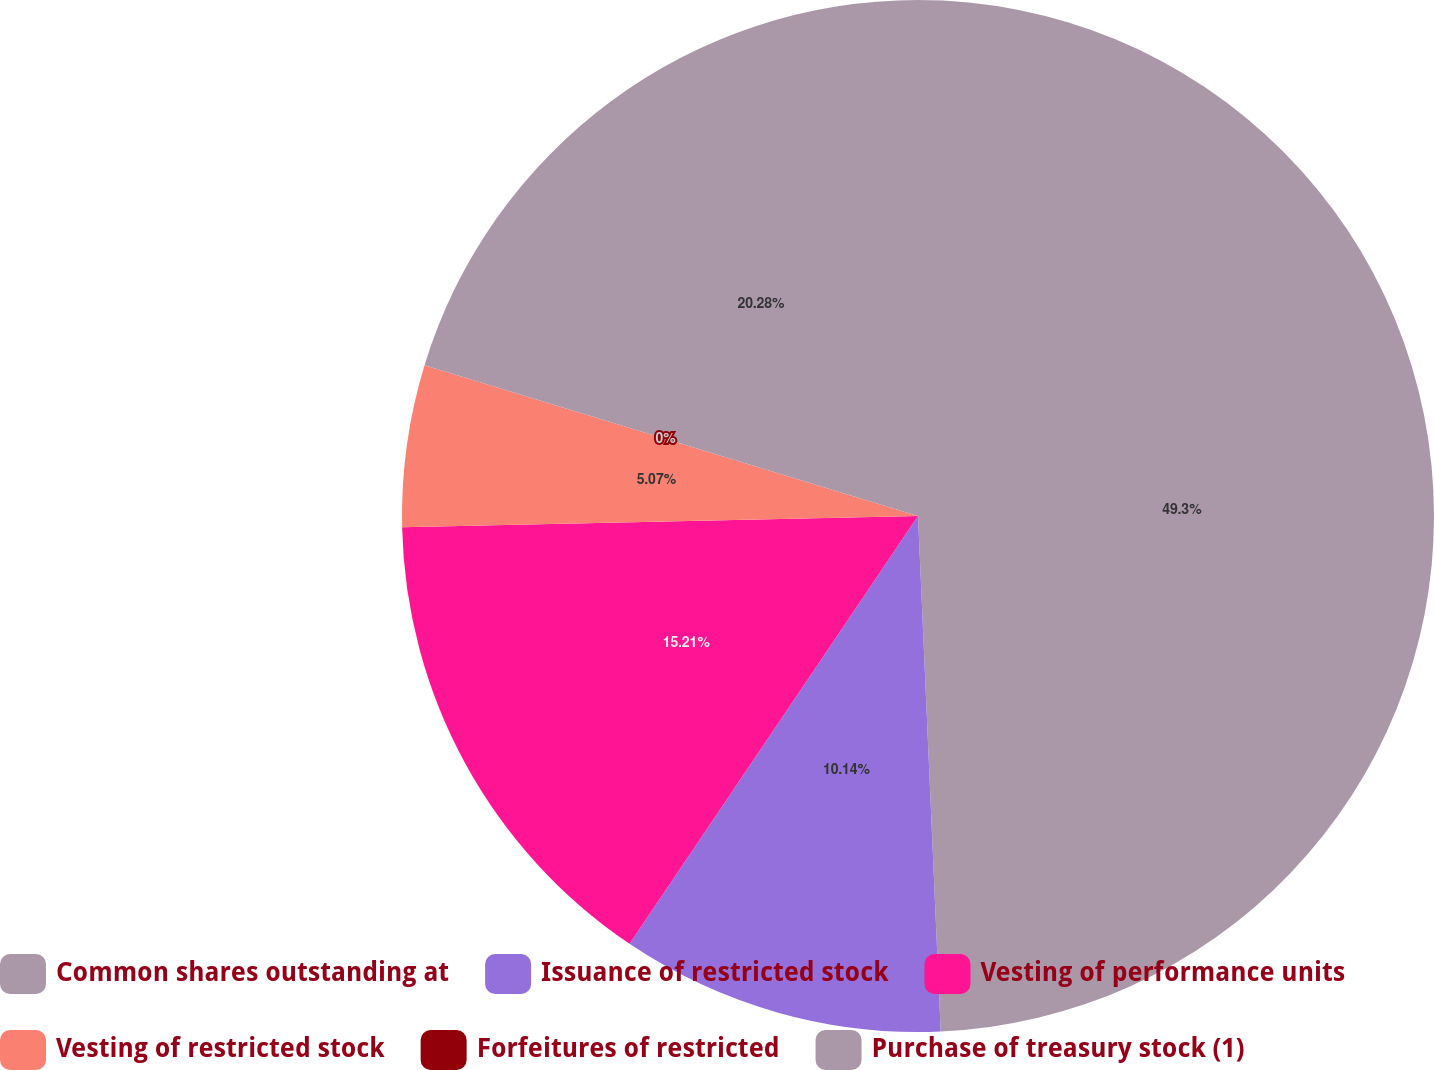Convert chart to OTSL. <chart><loc_0><loc_0><loc_500><loc_500><pie_chart><fcel>Common shares outstanding at<fcel>Issuance of restricted stock<fcel>Vesting of performance units<fcel>Vesting of restricted stock<fcel>Forfeitures of restricted<fcel>Purchase of treasury stock (1)<nl><fcel>49.3%<fcel>10.14%<fcel>15.21%<fcel>5.07%<fcel>0.0%<fcel>20.28%<nl></chart> 